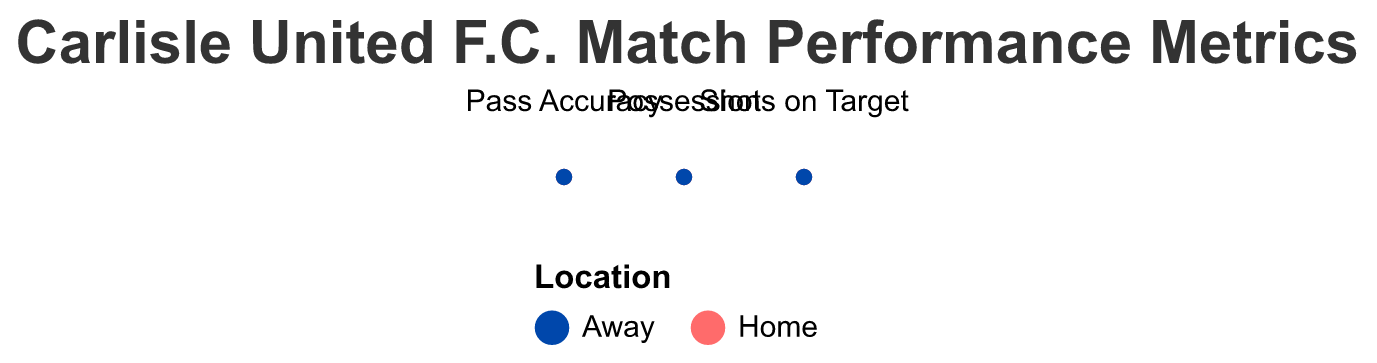What is the title of the figure? The title is displayed at the top of the figure and reads "Carlisle United F.C. Match Performance Metrics."
Answer: Carlisle United F.C. Match Performance Metrics What colors are used to differentiate between home and away games? The color representing home games is blue while the color representing away games is red. These colors can be observed in the legend and used in the plot lines.
Answer: Blue (Home) and Red (Away) What is the average possession during home games? Locate the "Possession" metric under home games on the plot and refer to the tooltip to find the average value.
Answer: 57.3 Which metric shows a greater difference between home and away games, Pass Accuracy or Shots on Target? Calculate the average difference between home and away for both metrics. For Pass Accuracy: Home (80) - Away (72.3) = 7.7. For Shots on Target: Home (7) - Away (6) = 1. Therefore, Pass Accuracy shows a greater difference.
Answer: Pass Accuracy What is the average Pass Accuracy for away games? Locate the "Pass Accuracy" metric under away games on the plot and refer to the tooltip to find the average value.
Answer: 72.3 Which metric has the highest average value during home games? Compare the average values of "Possession," "Pass Accuracy," and "Shots on Target" for home games. Highest value: Pass Accuracy with 80.0
Answer: Pass Accuracy Is the average Shots on Target higher in home or away games? Compare the average values for "Shots on Target" in home and away games by referring to the plot's tooltip. Home: 7, Away: 6.
Answer: Home What is the average Possession value for away games? Average the Possession values recorded for away locations. The values are 46, 50, 55. So, (46 + 50 + 55) / 3 = 50.3
Answer: 50.3 Does Carlisle United F.C. have a higher average Pass Accuracy at home compared to away games? Compare the Pass Accuracy averages for home and away games found in the plot's tooltip. Home: 80, Away: 72.3. The home average is higher.
Answer: Yes 